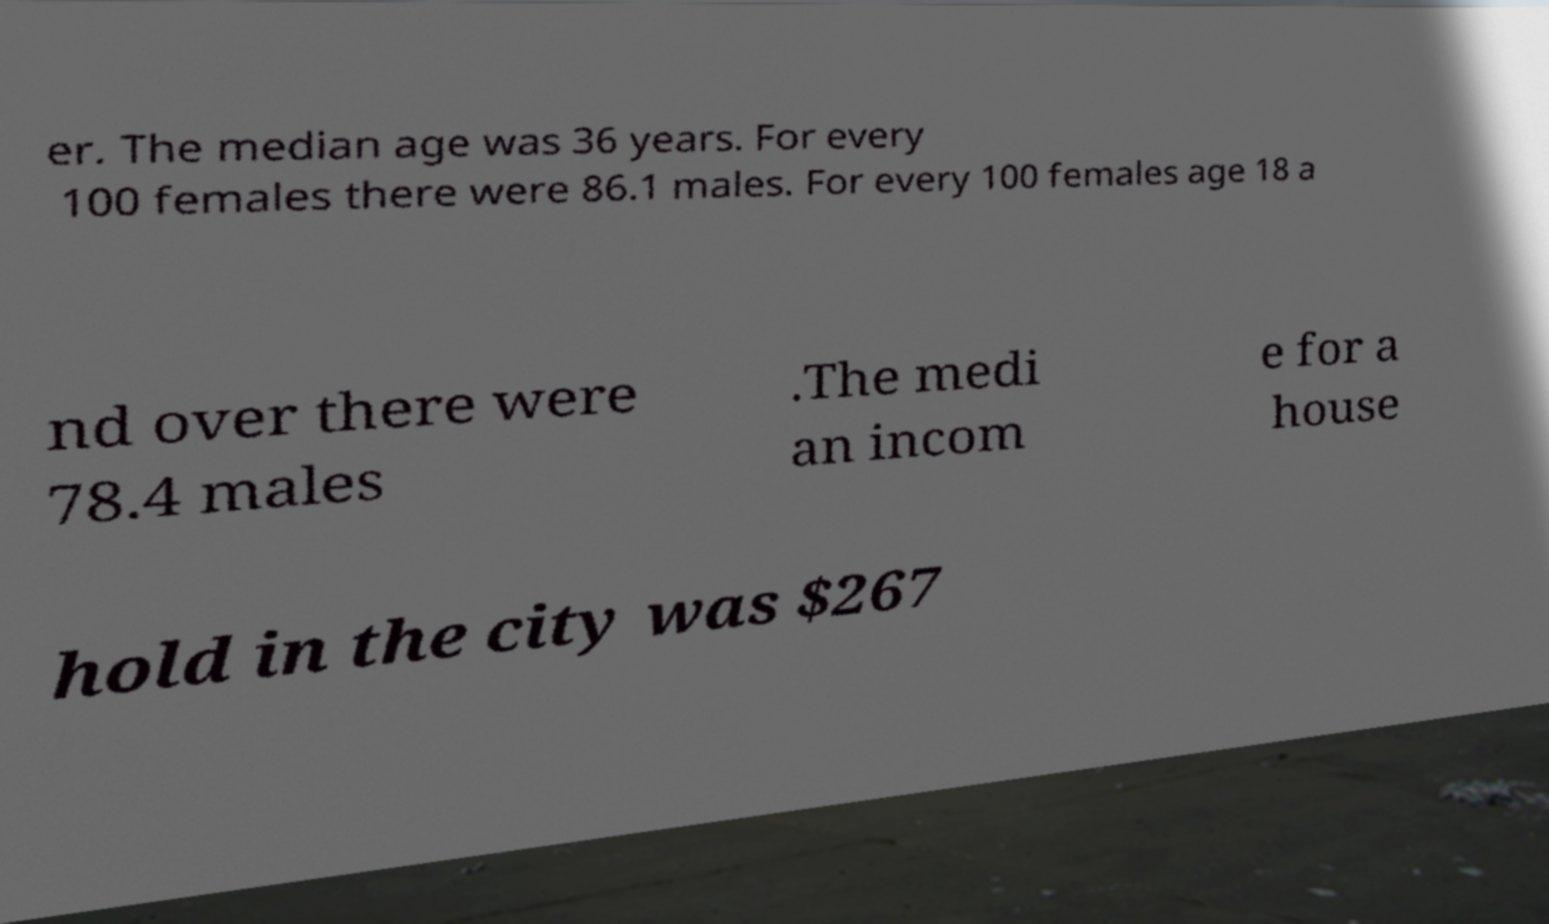I need the written content from this picture converted into text. Can you do that? er. The median age was 36 years. For every 100 females there were 86.1 males. For every 100 females age 18 a nd over there were 78.4 males .The medi an incom e for a house hold in the city was $267 